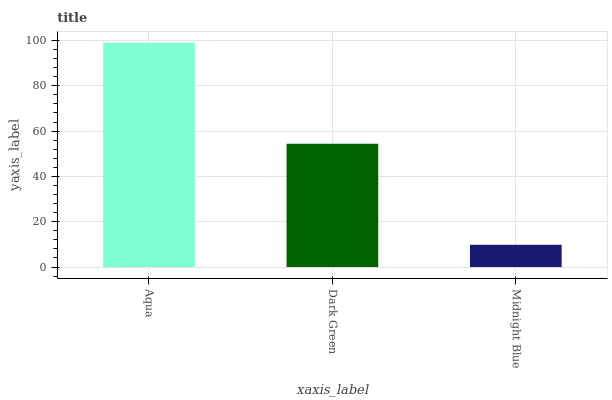Is Midnight Blue the minimum?
Answer yes or no. Yes. Is Aqua the maximum?
Answer yes or no. Yes. Is Dark Green the minimum?
Answer yes or no. No. Is Dark Green the maximum?
Answer yes or no. No. Is Aqua greater than Dark Green?
Answer yes or no. Yes. Is Dark Green less than Aqua?
Answer yes or no. Yes. Is Dark Green greater than Aqua?
Answer yes or no. No. Is Aqua less than Dark Green?
Answer yes or no. No. Is Dark Green the high median?
Answer yes or no. Yes. Is Dark Green the low median?
Answer yes or no. Yes. Is Midnight Blue the high median?
Answer yes or no. No. Is Midnight Blue the low median?
Answer yes or no. No. 